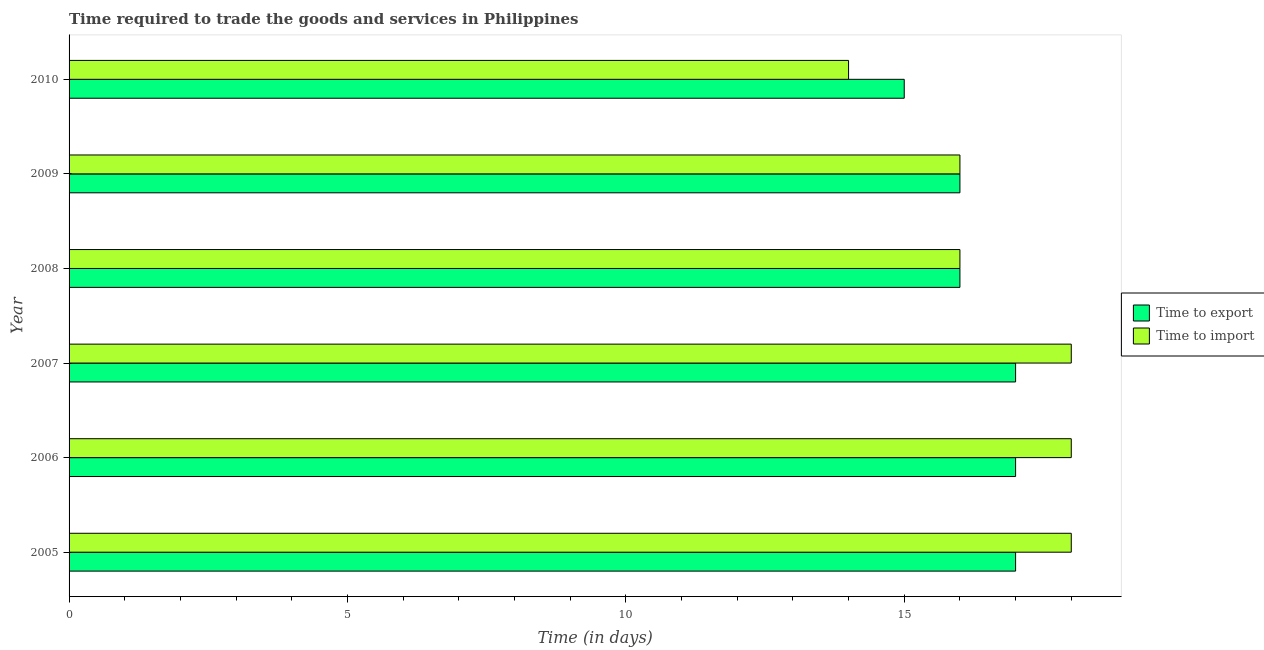Are the number of bars per tick equal to the number of legend labels?
Ensure brevity in your answer.  Yes. Are the number of bars on each tick of the Y-axis equal?
Keep it short and to the point. Yes. How many bars are there on the 5th tick from the bottom?
Your response must be concise. 2. What is the time to export in 2005?
Offer a terse response. 17. Across all years, what is the maximum time to export?
Offer a terse response. 17. Across all years, what is the minimum time to export?
Your response must be concise. 15. In which year was the time to export minimum?
Keep it short and to the point. 2010. What is the total time to import in the graph?
Your answer should be compact. 100. What is the difference between the time to export in 2006 and the time to import in 2008?
Your response must be concise. 1. What is the average time to import per year?
Your response must be concise. 16.67. In the year 2006, what is the difference between the time to import and time to export?
Ensure brevity in your answer.  1. In how many years, is the time to import greater than 14 days?
Offer a very short reply. 5. What is the ratio of the time to export in 2007 to that in 2010?
Make the answer very short. 1.13. Is the difference between the time to import in 2005 and 2006 greater than the difference between the time to export in 2005 and 2006?
Provide a succinct answer. No. What is the difference between the highest and the second highest time to import?
Make the answer very short. 0. What is the difference between the highest and the lowest time to export?
Make the answer very short. 2. In how many years, is the time to import greater than the average time to import taken over all years?
Your response must be concise. 3. What does the 2nd bar from the top in 2010 represents?
Keep it short and to the point. Time to export. What does the 2nd bar from the bottom in 2009 represents?
Provide a succinct answer. Time to import. How many bars are there?
Your answer should be very brief. 12. Are all the bars in the graph horizontal?
Your answer should be compact. Yes. Are the values on the major ticks of X-axis written in scientific E-notation?
Give a very brief answer. No. Does the graph contain any zero values?
Your response must be concise. No. Does the graph contain grids?
Give a very brief answer. No. Where does the legend appear in the graph?
Provide a succinct answer. Center right. How many legend labels are there?
Offer a very short reply. 2. What is the title of the graph?
Offer a very short reply. Time required to trade the goods and services in Philippines. Does "Primary education" appear as one of the legend labels in the graph?
Give a very brief answer. No. What is the label or title of the X-axis?
Provide a succinct answer. Time (in days). What is the Time (in days) in Time to export in 2006?
Keep it short and to the point. 17. What is the Time (in days) in Time to import in 2008?
Your answer should be compact. 16. What is the Time (in days) of Time to export in 2010?
Your answer should be very brief. 15. Across all years, what is the maximum Time (in days) in Time to export?
Your answer should be very brief. 17. Across all years, what is the minimum Time (in days) in Time to export?
Provide a short and direct response. 15. Across all years, what is the minimum Time (in days) of Time to import?
Offer a terse response. 14. What is the total Time (in days) in Time to export in the graph?
Ensure brevity in your answer.  98. What is the total Time (in days) of Time to import in the graph?
Provide a short and direct response. 100. What is the difference between the Time (in days) in Time to export in 2005 and that in 2006?
Provide a succinct answer. 0. What is the difference between the Time (in days) of Time to import in 2005 and that in 2008?
Ensure brevity in your answer.  2. What is the difference between the Time (in days) of Time to export in 2005 and that in 2009?
Provide a succinct answer. 1. What is the difference between the Time (in days) of Time to export in 2005 and that in 2010?
Ensure brevity in your answer.  2. What is the difference between the Time (in days) of Time to import in 2006 and that in 2007?
Your answer should be compact. 0. What is the difference between the Time (in days) in Time to export in 2006 and that in 2008?
Your response must be concise. 1. What is the difference between the Time (in days) of Time to import in 2006 and that in 2009?
Provide a short and direct response. 2. What is the difference between the Time (in days) in Time to export in 2006 and that in 2010?
Keep it short and to the point. 2. What is the difference between the Time (in days) in Time to import in 2007 and that in 2008?
Ensure brevity in your answer.  2. What is the difference between the Time (in days) in Time to import in 2007 and that in 2009?
Give a very brief answer. 2. What is the difference between the Time (in days) in Time to import in 2007 and that in 2010?
Make the answer very short. 4. What is the difference between the Time (in days) in Time to export in 2008 and that in 2009?
Your response must be concise. 0. What is the difference between the Time (in days) of Time to import in 2008 and that in 2009?
Your answer should be very brief. 0. What is the difference between the Time (in days) in Time to export in 2008 and that in 2010?
Ensure brevity in your answer.  1. What is the difference between the Time (in days) of Time to import in 2008 and that in 2010?
Give a very brief answer. 2. What is the difference between the Time (in days) of Time to export in 2009 and that in 2010?
Your response must be concise. 1. What is the difference between the Time (in days) of Time to import in 2009 and that in 2010?
Make the answer very short. 2. What is the difference between the Time (in days) in Time to export in 2005 and the Time (in days) in Time to import in 2010?
Offer a very short reply. 3. What is the difference between the Time (in days) of Time to export in 2006 and the Time (in days) of Time to import in 2008?
Provide a short and direct response. 1. What is the difference between the Time (in days) in Time to export in 2006 and the Time (in days) in Time to import in 2010?
Offer a very short reply. 3. What is the difference between the Time (in days) of Time to export in 2007 and the Time (in days) of Time to import in 2008?
Give a very brief answer. 1. What is the difference between the Time (in days) in Time to export in 2007 and the Time (in days) in Time to import in 2009?
Offer a very short reply. 1. What is the difference between the Time (in days) of Time to export in 2008 and the Time (in days) of Time to import in 2009?
Provide a succinct answer. 0. What is the difference between the Time (in days) in Time to export in 2008 and the Time (in days) in Time to import in 2010?
Keep it short and to the point. 2. What is the average Time (in days) in Time to export per year?
Give a very brief answer. 16.33. What is the average Time (in days) in Time to import per year?
Keep it short and to the point. 16.67. In the year 2005, what is the difference between the Time (in days) of Time to export and Time (in days) of Time to import?
Your response must be concise. -1. In the year 2006, what is the difference between the Time (in days) of Time to export and Time (in days) of Time to import?
Your answer should be very brief. -1. In the year 2008, what is the difference between the Time (in days) in Time to export and Time (in days) in Time to import?
Your answer should be very brief. 0. In the year 2010, what is the difference between the Time (in days) in Time to export and Time (in days) in Time to import?
Make the answer very short. 1. What is the ratio of the Time (in days) of Time to export in 2005 to that in 2006?
Offer a very short reply. 1. What is the ratio of the Time (in days) of Time to import in 2005 to that in 2006?
Keep it short and to the point. 1. What is the ratio of the Time (in days) in Time to import in 2005 to that in 2007?
Offer a very short reply. 1. What is the ratio of the Time (in days) of Time to export in 2005 to that in 2008?
Offer a very short reply. 1.06. What is the ratio of the Time (in days) in Time to import in 2005 to that in 2008?
Your response must be concise. 1.12. What is the ratio of the Time (in days) in Time to export in 2005 to that in 2009?
Offer a terse response. 1.06. What is the ratio of the Time (in days) in Time to export in 2005 to that in 2010?
Your answer should be compact. 1.13. What is the ratio of the Time (in days) in Time to import in 2006 to that in 2007?
Ensure brevity in your answer.  1. What is the ratio of the Time (in days) of Time to export in 2006 to that in 2008?
Offer a very short reply. 1.06. What is the ratio of the Time (in days) of Time to import in 2006 to that in 2008?
Keep it short and to the point. 1.12. What is the ratio of the Time (in days) of Time to export in 2006 to that in 2009?
Provide a succinct answer. 1.06. What is the ratio of the Time (in days) of Time to import in 2006 to that in 2009?
Make the answer very short. 1.12. What is the ratio of the Time (in days) of Time to export in 2006 to that in 2010?
Your answer should be compact. 1.13. What is the ratio of the Time (in days) of Time to import in 2006 to that in 2010?
Offer a very short reply. 1.29. What is the ratio of the Time (in days) in Time to import in 2007 to that in 2008?
Keep it short and to the point. 1.12. What is the ratio of the Time (in days) in Time to import in 2007 to that in 2009?
Provide a succinct answer. 1.12. What is the ratio of the Time (in days) of Time to export in 2007 to that in 2010?
Offer a terse response. 1.13. What is the ratio of the Time (in days) in Time to export in 2008 to that in 2009?
Ensure brevity in your answer.  1. What is the ratio of the Time (in days) in Time to export in 2008 to that in 2010?
Ensure brevity in your answer.  1.07. What is the ratio of the Time (in days) of Time to import in 2008 to that in 2010?
Your answer should be compact. 1.14. What is the ratio of the Time (in days) in Time to export in 2009 to that in 2010?
Your answer should be very brief. 1.07. What is the ratio of the Time (in days) in Time to import in 2009 to that in 2010?
Keep it short and to the point. 1.14. What is the difference between the highest and the second highest Time (in days) of Time to import?
Keep it short and to the point. 0. 